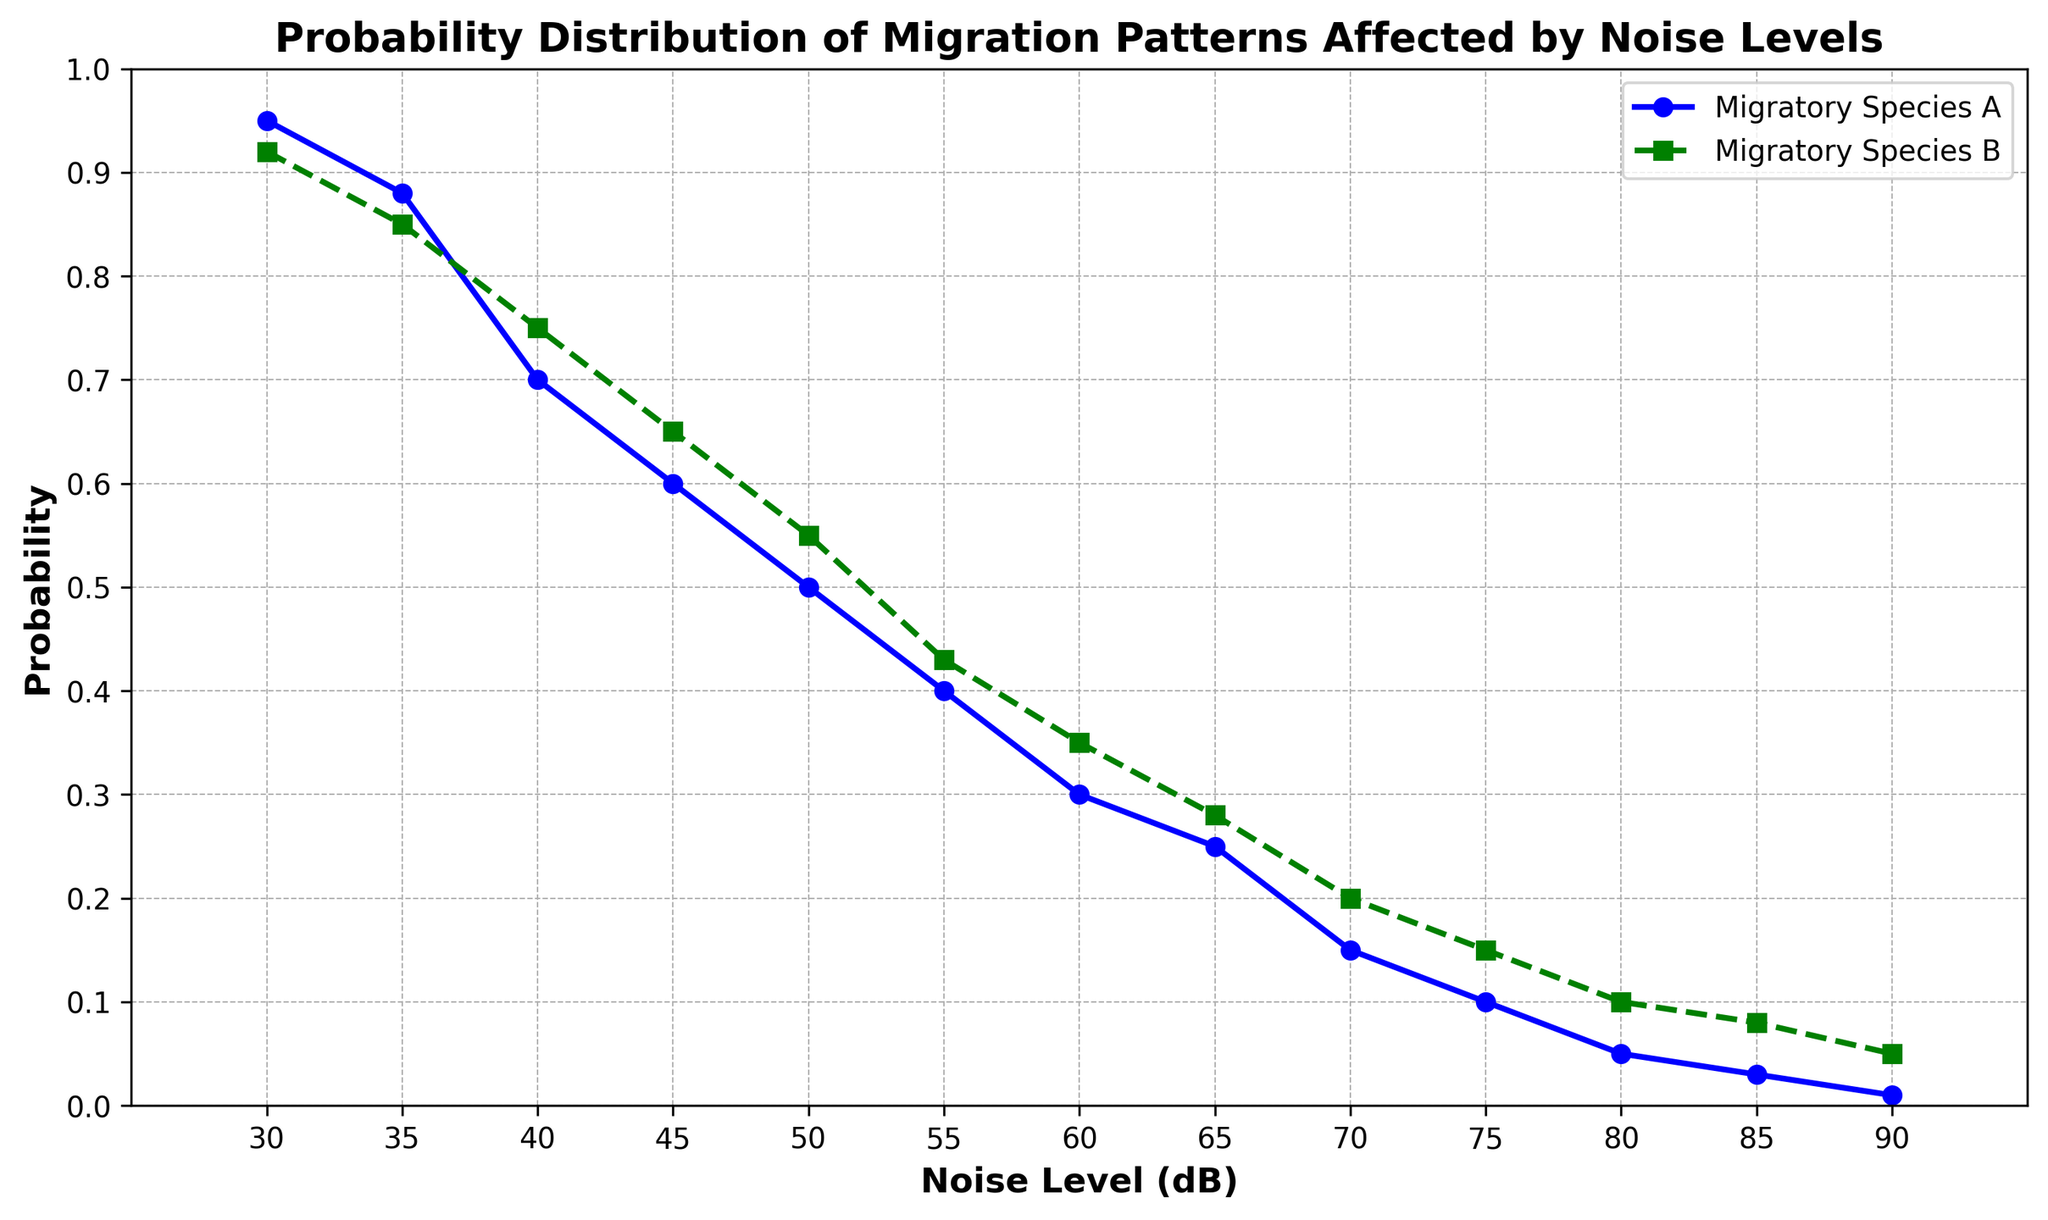Which species has a higher probability at 60 dB noise level? At 60 dB, follow the data points on the x-axis and check the y-axis values for both species. Migratory Species A has a probability of 0.30, while Migratory Species B has a probability of 0.35.
Answer: Migratory Species B What is the difference in probability between the two species at 35 dB noise level? Identify the probabilities at 35 dB for both species from the plot. Migratory Species A has a probability of 0.88, and Migratory Species B has a probability of 0.85. Subtract these two values to find the difference: 0.88 - 0.85.
Answer: 0.03 At what noise level do both species have a probability below 0.10? Look for the points on the x-axis where both species have probabilities lower than 0.10. The data indicates that both probabilities drop below 0.10 at 80 dB.
Answer: 80 dB How does the probability of Migratory Species A change from 30 dB to 50 dB? Observe the probabilities for Migratory Species A at 30 dB and 50 dB on the y-axis. At 30 dB, the probability is 0.95, and at 50 dB, it is 0.50. Calculate the change: 0.95 - 0.50.
Answer: Decreases by 0.45 Which species shows a steeper decline in probability as noise levels increase from 30 dB to 70 dB? Compare the slopes of the lines for both species between 30 dB and 70 dB. Migratory Species A declines from 0.95 to 0.15, and Migratory Species B declines from 0.92 to 0.20. The difference for Species A is 0.95 - 0.15 = 0.80 and for Species B is 0.92 - 0.20 = 0.72. Species A shows a steeper decline.
Answer: Migratory Species A What is the average probability of Migratory Species B when the noise level ranges from 40 dB to 60 dB? Sum the probabilities of Species B at 40, 45, 50, 55, and 60 dB: 0.75 + 0.65 + 0.55 + 0.43 + 0.35 = 2.73. Divide by the number of data points (5): 2.73 / 5.
Answer: 0.546 If the noise level is at 70 dB, by how much does the probability of Migratory Species A exceed that of Migratory Species B? At 70 dB, Species A has a probability of 0.15, and Species B has 0.20. The difference is 0.20 - 0.15.
Answer: 0.05 At 45 dB noise level, which species has a higher probability, and what is the probability difference? Check the probabilities at 45 dB on the y-axis. Species A has 0.60, and Species B has 0.65. The difference is 0.65 - 0.60.
Answer: Migratory Species B, 0.05 What is the probability range for Migratory Species A from 55 dB to 85 dB? Identify the minimum and maximum probabilities of Species A within this noise level range: values are 0.40 (at 55 dB) to 0.01 (at 90 dB). The range is from these values.
Answer: 0.01 to 0.40 